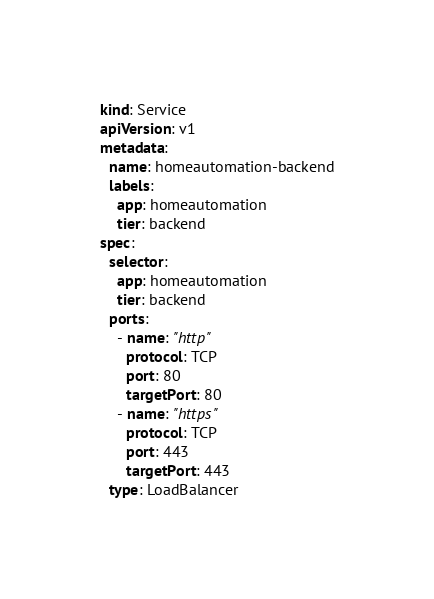<code> <loc_0><loc_0><loc_500><loc_500><_YAML_>kind: Service
apiVersion: v1
metadata:
  name: homeautomation-backend
  labels:
    app: homeautomation
    tier: backend
spec:
  selector:
    app: homeautomation
    tier: backend
  ports:
    - name: "http"
      protocol: TCP
      port: 80
      targetPort: 80
    - name: "https"
      protocol: TCP
      port: 443
      targetPort: 443
  type: LoadBalancer
</code> 